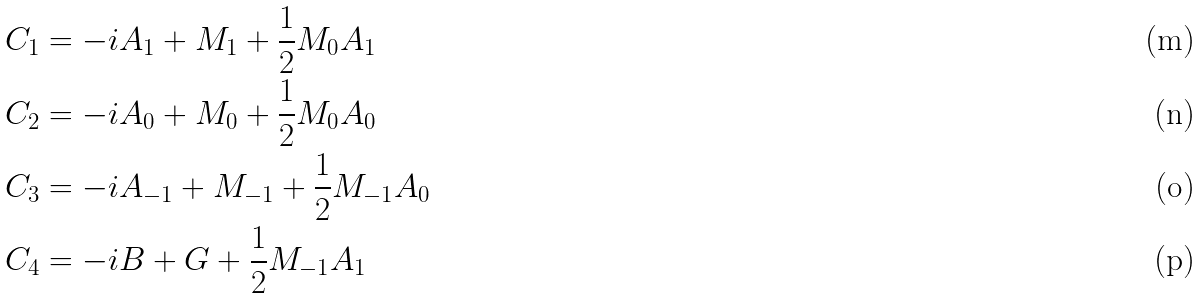<formula> <loc_0><loc_0><loc_500><loc_500>C _ { 1 } & = - i A _ { 1 } + M _ { 1 } + \frac { 1 } { 2 } M _ { 0 } A _ { 1 } \\ C _ { 2 } & = - i A _ { 0 } + M _ { 0 } + \frac { 1 } { 2 } M _ { 0 } A _ { 0 } \\ C _ { 3 } & = - i A _ { - 1 } + M _ { - 1 } + \frac { 1 } { 2 } M _ { - 1 } A _ { 0 } \\ C _ { 4 } & = - i B + G + \frac { 1 } { 2 } M _ { - 1 } A _ { 1 }</formula> 